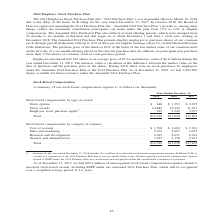According to A10 Networks's financial document, What is the amount of employee stock purchase rights including accelerated stock-based compensation expense at the end of 2019? According to the financial document, 999 (in thousands). The relevant text states: "0,445 11,421 Employee stock purchase rights (1) . 999 5,240 3,077..." Also, What is the amount of employee stock purchase rights including accelerated stock-based compensation expense at the end of 2018? According to the financial document, 5,240 (in thousands). The relevant text states: "5 11,421 Employee stock purchase rights (1) . 999 5,240 3,077..." Also, What is the amount of employee stock purchase rights including accelerated stock-based compensation expense at the end of 2017? According to the financial document, 3,077 (in thousands). The relevant text states: "21 Employee stock purchase rights (1) . 999 5,240 3,077..." Also, can you calculate: What is the percentage change in total stock base compensation  by type of award between 2018 and 2019? To answer this question, I need to perform calculations using the financial data. The calculation is: (16,529 - 17,038)/17,038 , which equals -2.99 (percentage). This is based on the information: "Total. . $16,529 $17,038 $17,203 Total. . $16,529 $17,038 $17,203..." The key data points involved are: 16,529, 17,038. Also, can you calculate: What is the total stock based compensation amount between 2017 to 2019? Based on the calculation: $16,529 + $17,038 + $17,203, the result is 50770 (in thousands). This is based on the information: "Total. . $16,529 $17,038 $17,203 Total. . $16,529 $17,038 $17,203 Total. . $16,529 $17,038 $17,203..." The key data points involved are: 16,529, 17,038, 17,203. Also, can you calculate: What is the percentage change in stock based compensation on sales and marketing between 2018 and 2019? To answer this question, I need to perform calculations using the financial data. The calculation is: (5,765 - 5,667)/5,667 , which equals 1.73 (percentage). This is based on the information: "1,500 $ 1,602 $ 1,362 Sales and marketing . 5,765 5,667 6,075 Research and development . 6,039 6,631 6,343 General and administrative . 3,225 3,138 3,423 e . $ 1,500 $ 1,602 $ 1,362 Sales and marketin..." The key data points involved are: 5,667, 5,765. 